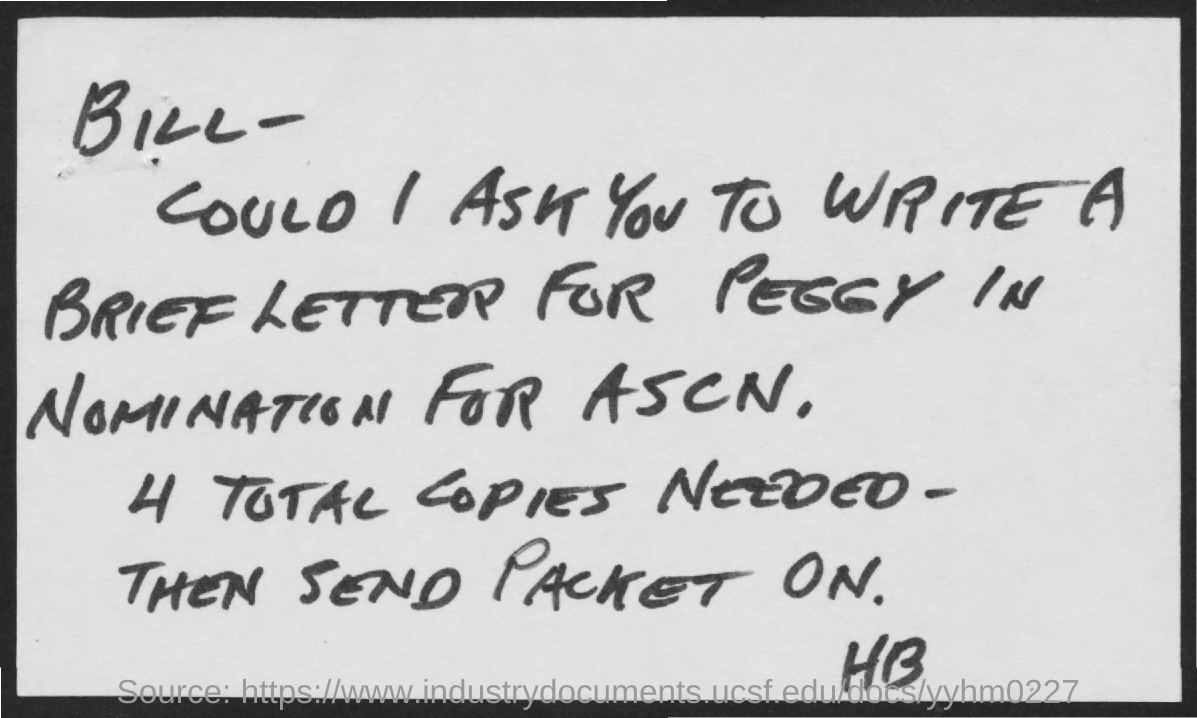Outline some significant characteristics in this image. In total, 4 copies are needed as per the letter. The letter is addressed to BILL. 